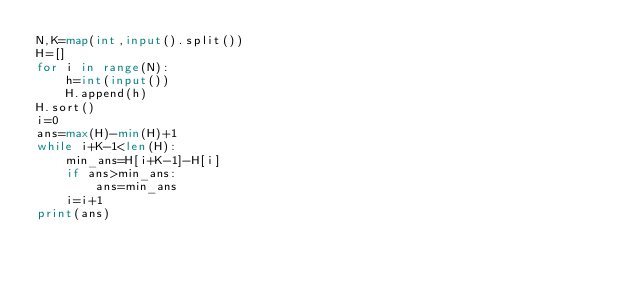Convert code to text. <code><loc_0><loc_0><loc_500><loc_500><_Python_>N,K=map(int,input().split())
H=[]
for i in range(N):
    h=int(input())
    H.append(h)
H.sort()
i=0
ans=max(H)-min(H)+1
while i+K-1<len(H):
    min_ans=H[i+K-1]-H[i]
    if ans>min_ans:
        ans=min_ans
    i=i+1
print(ans)
</code> 